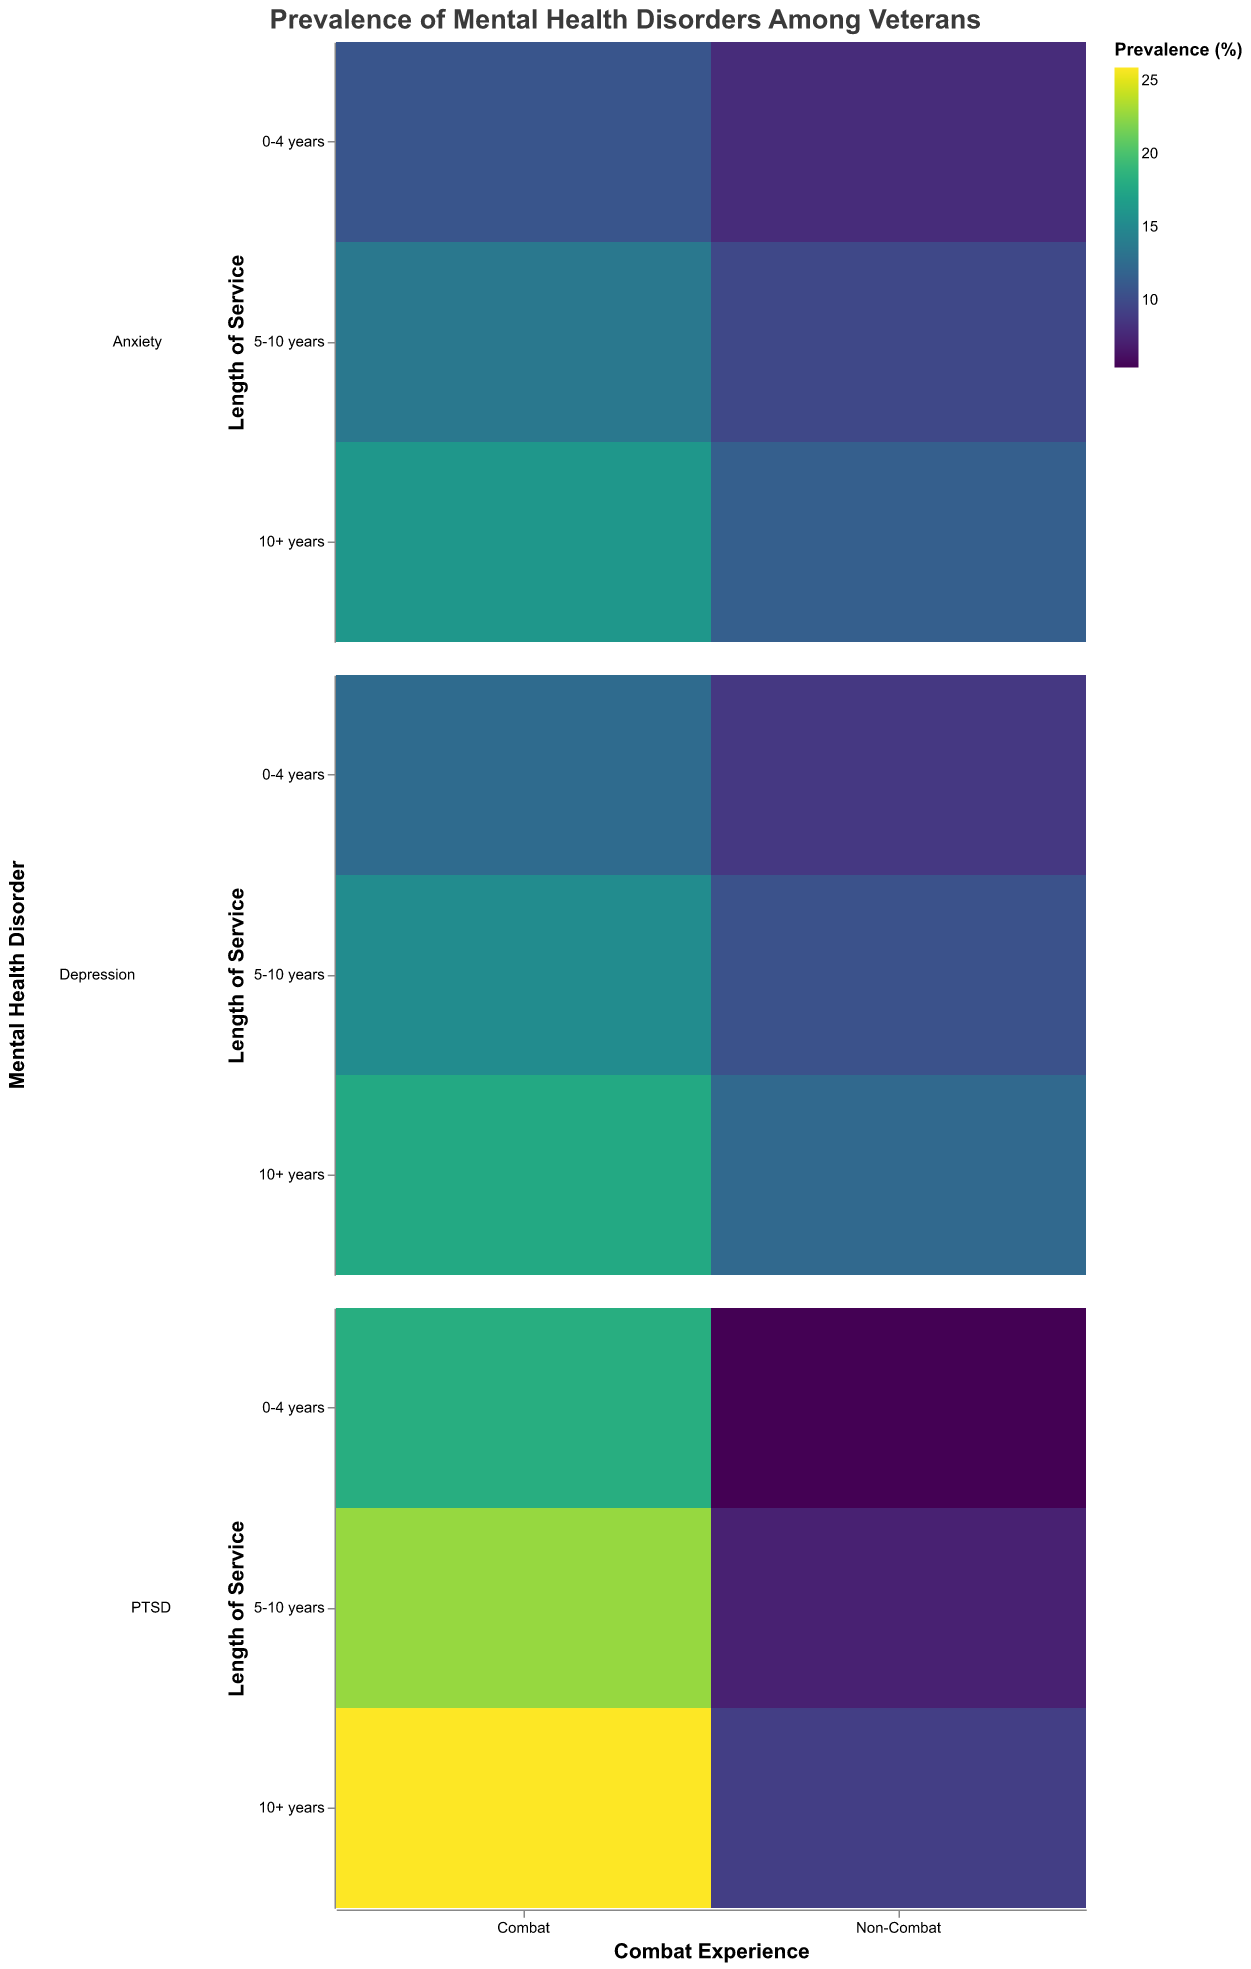What is the prevalence of PTSD among veterans with 5-10 years of non-combat experience? Locate the section for non-combat veterans with 5-10 years of service and find the value for PTSD. The color scale or tooltip will show 7.2%.
Answer: 7.2% Which mental health disorder is most prevalent among combat veterans with 10+ years of service? Refer to the section for combat veterans with 10+ years of service. Compare the prevalence values for PTSD, Depression, and Anxiety. The highest is PTSD at 25.9%.
Answer: PTSD How does the prevalence of anxiety among combat veterans with 0-4 years of service compare to non-combat veterans with the same years of service? Find the prevalence of anxiety for both groups. For combat it’s 10.8%, and for non-combat it’s 7.9%.
Answer: Combat veterans have a higher prevalence What is the difference in PTSD prevalence between combat and non-combat veterans with 5-10 years of service? Locate PTSD values for both groups: combat veterans have 22.7% and non-combat veterans have 7.2%. Subtract the non-combat value from the combat value: 22.7% - 7.2% = 15.5%.
Answer: 15.5% If you average the prevalence of Depression across all non-combat groups, what value do you get? Sum the prevalence of Depression for non-combat veterans: 8.7% (0-4 years) + 10.5% (5-10 years) + 12.3% (10+ years) = 31.5%. Divide by 3 (number of groups): 31.5% / 3 = 10.5%.
Answer: 10.5% Which length of service has the highest prevalence of anxiety among combat veterans? Look at the values for anxiety in combat veterans across different lengths of service. 0-4 years (10.8%), 5-10 years (13.6%), and 10+ years (16.2%). The highest is 10+ years.
Answer: 10+ years What is the color scheme used in the plot to represent the prevalence values? The color scheme is mentioned as 'viridis' in the configuration, representing a range from low to high prevalence with corresponding color gradients.
Answer: viridis Is the prevalence of PTSD consistently higher among combat veterans than non-combat veterans across all service lengths? Compare the PTSD prevalence for combat and non-combat veterans for each service length: 0-4 years (Combat: 18.2%, Non-Combat: 5.4%), 5-10 years (Combat: 22.7%, Non-Combat: 7.2%), 10+ years (Combat: 25.9%, Non-Combat: 9.1%). In each case, combat is higher.
Answer: Yes What’s the total prevalence of mental health disorders for combat veterans with 0-4 years of service? Add prevalence percentages of all disorders: PTSD (18.2%) + Depression (12.5%) + Anxiety (10.8%) = 41.5%.
Answer: 41.5% How does the prevalence of Depression among non-combat veterans with 10+ years compare to non-combat veterans with 0-4 years? Locate the prevalence values for Depression in non-combat veterans: 10+ years (12.3%) and 0-4 years (8.7%). 12.3% is higher than 8.7%.
Answer: 12.3% is higher than 8.7% 